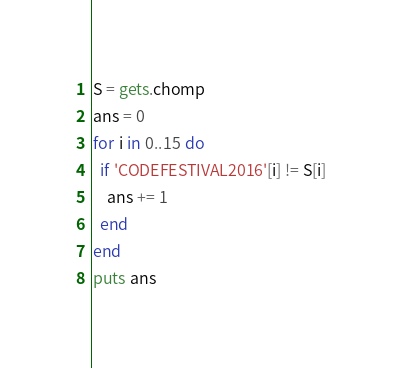Convert code to text. <code><loc_0><loc_0><loc_500><loc_500><_Ruby_>S = gets.chomp
ans = 0
for i in 0..15 do
  if 'CODEFESTIVAL2016'[i] != S[i]
    ans += 1
  end
end
puts ans</code> 